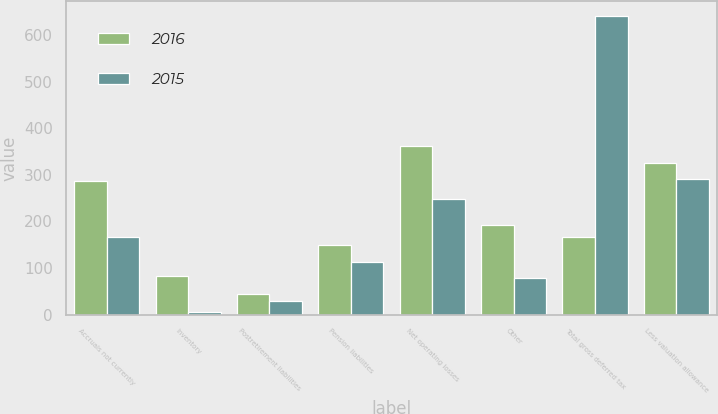Convert chart. <chart><loc_0><loc_0><loc_500><loc_500><stacked_bar_chart><ecel><fcel>Accruals not currently<fcel>Inventory<fcel>Postretirement liabilities<fcel>Pension liabilities<fcel>Net operating losses<fcel>Other<fcel>Total gross deferred tax<fcel>Less valuation allowance<nl><fcel>2016<fcel>285.8<fcel>83.9<fcel>44<fcel>149.8<fcel>361.3<fcel>193<fcel>166.9<fcel>325.3<nl><fcel>2015<fcel>166.9<fcel>4.8<fcel>28.6<fcel>113.5<fcel>248.3<fcel>78.8<fcel>640.9<fcel>291<nl></chart> 